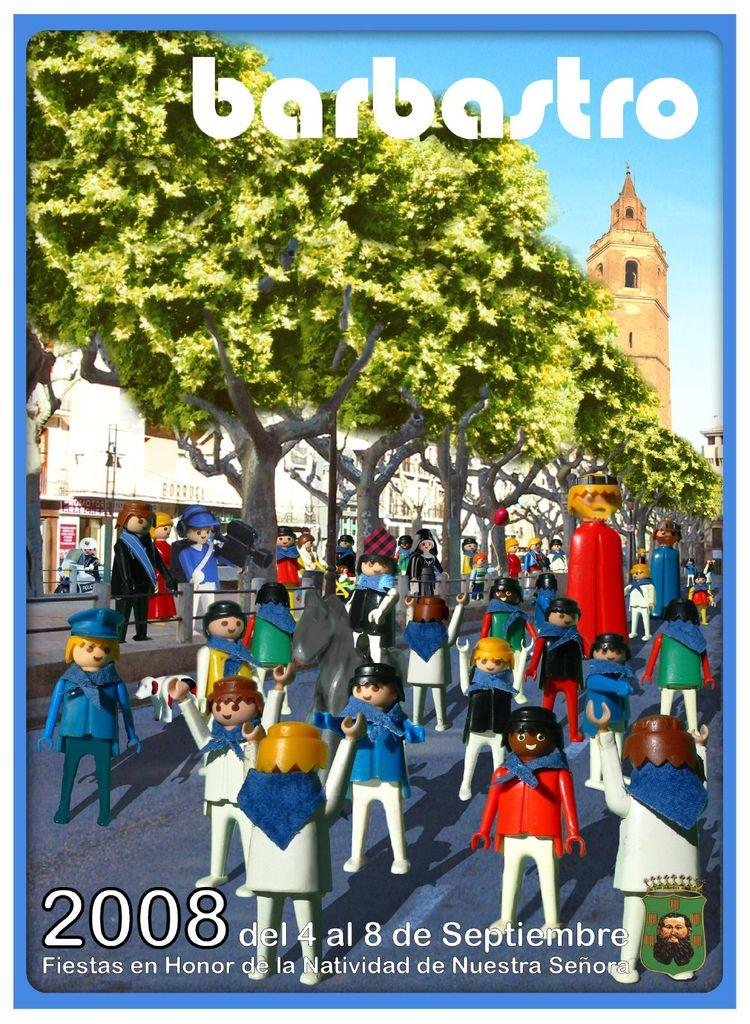<image>
Create a compact narrative representing the image presented. Barbastro play people standing around outside in 2008 